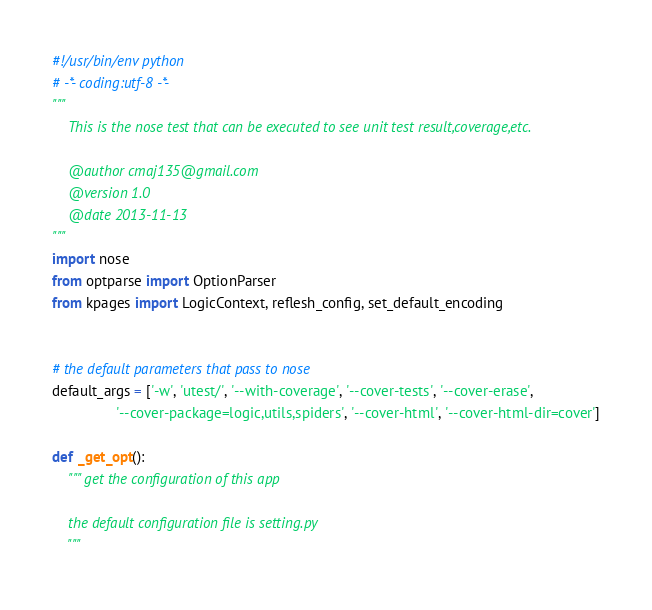Convert code to text. <code><loc_0><loc_0><loc_500><loc_500><_Python_>#!/usr/bin/env python
# -*- coding:utf-8 -*-
"""
    This is the nose test that can be executed to see unit test result,coverage,etc.

    @author cmaj135@gmail.com
    @version 1.0
    @date 2013-11-13
"""
import nose
from optparse import OptionParser
from kpages import LogicContext, reflesh_config, set_default_encoding


# the default parameters that pass to nose
default_args = ['-w', 'utest/', '--with-coverage', '--cover-tests', '--cover-erase',
                '--cover-package=logic,utils,spiders', '--cover-html', '--cover-html-dir=cover']

def _get_opt():
    """ get the configuration of this app

    the default configuration file is setting.py
    """</code> 